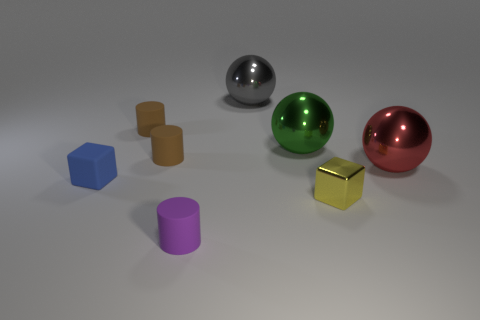Are the colors of the objects true or modified in some way? The colors appear to be true and unmodified, potentially aiming to show a natural representation of each object's color under the lighting conditions present in the scene.  Does the image suggest any particular use for these objects, as they are arranged? The arrangement of the objects does not imply a specific practical use; rather, it seems to be a deliberate composition made for aesthetic or display purposes, such as a demonstration of shapes, materials, and colors within a 3D rendering or graphics context. 